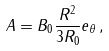<formula> <loc_0><loc_0><loc_500><loc_500>A = B _ { 0 } \frac { R ^ { 2 } } { 3 R _ { 0 } } e _ { \theta } \, ,</formula> 